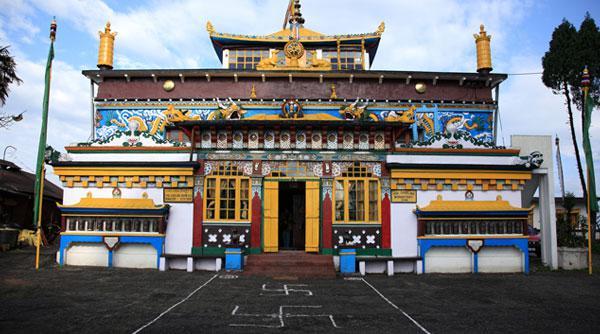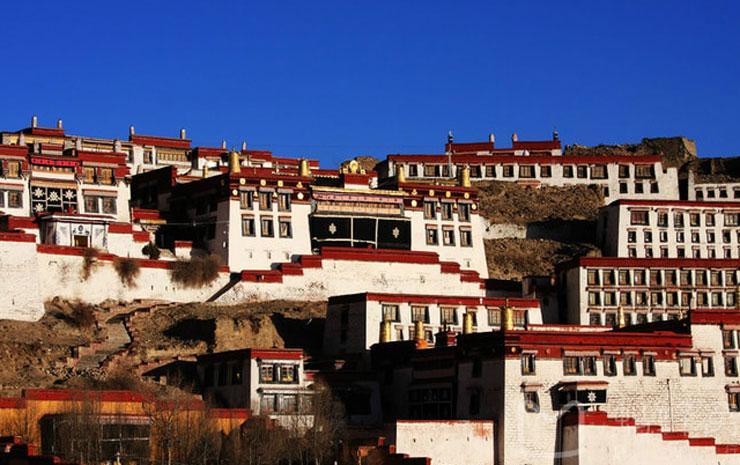The first image is the image on the left, the second image is the image on the right. Considering the images on both sides, is "To the right, we see a blue sky, with no clouds, behind the building." valid? Answer yes or no. Yes. The first image is the image on the left, the second image is the image on the right. Analyze the images presented: Is the assertion "Both images contain one single building, made of mostly right angles." valid? Answer yes or no. No. 